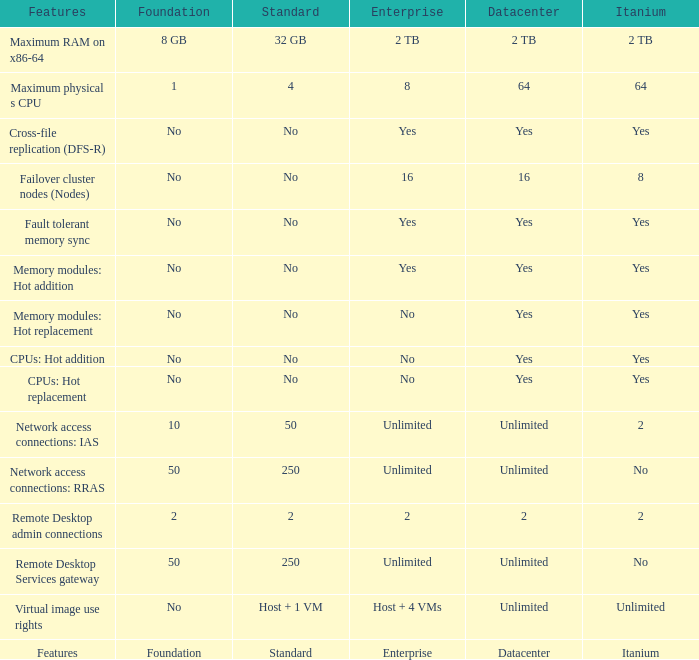Which enterprise feature involves hot replacement of memory modules and has a "yes" for data center compatibility? No. 